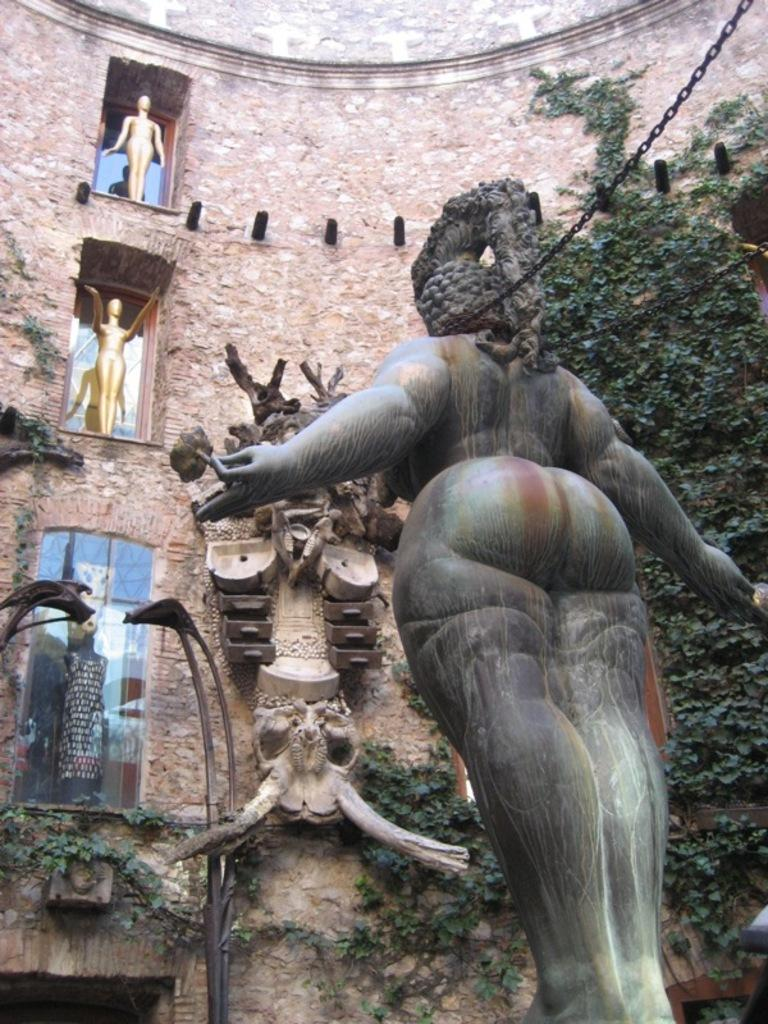What is the main subject in the image? There is a sculpture in the image. What can be seen behind the sculpture? There is a building and a tree behind the sculpture. What type of arithmetic problem is being solved by the sculpture in the image? There is no arithmetic problem being solved by the sculpture in the image; it is a static sculpture. 